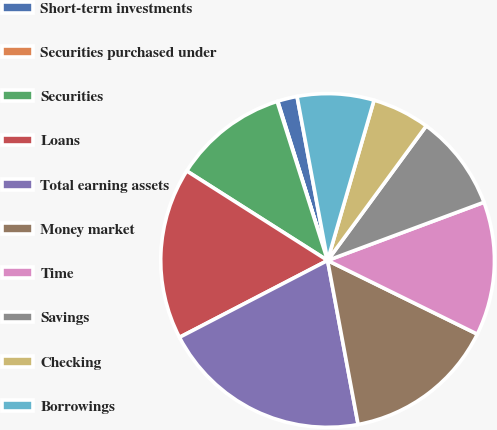Convert chart to OTSL. <chart><loc_0><loc_0><loc_500><loc_500><pie_chart><fcel>Short-term investments<fcel>Securities purchased under<fcel>Securities<fcel>Loans<fcel>Total earning assets<fcel>Money market<fcel>Time<fcel>Savings<fcel>Checking<fcel>Borrowings<nl><fcel>1.9%<fcel>0.06%<fcel>11.1%<fcel>16.63%<fcel>20.31%<fcel>14.79%<fcel>12.95%<fcel>9.26%<fcel>5.58%<fcel>7.42%<nl></chart> 